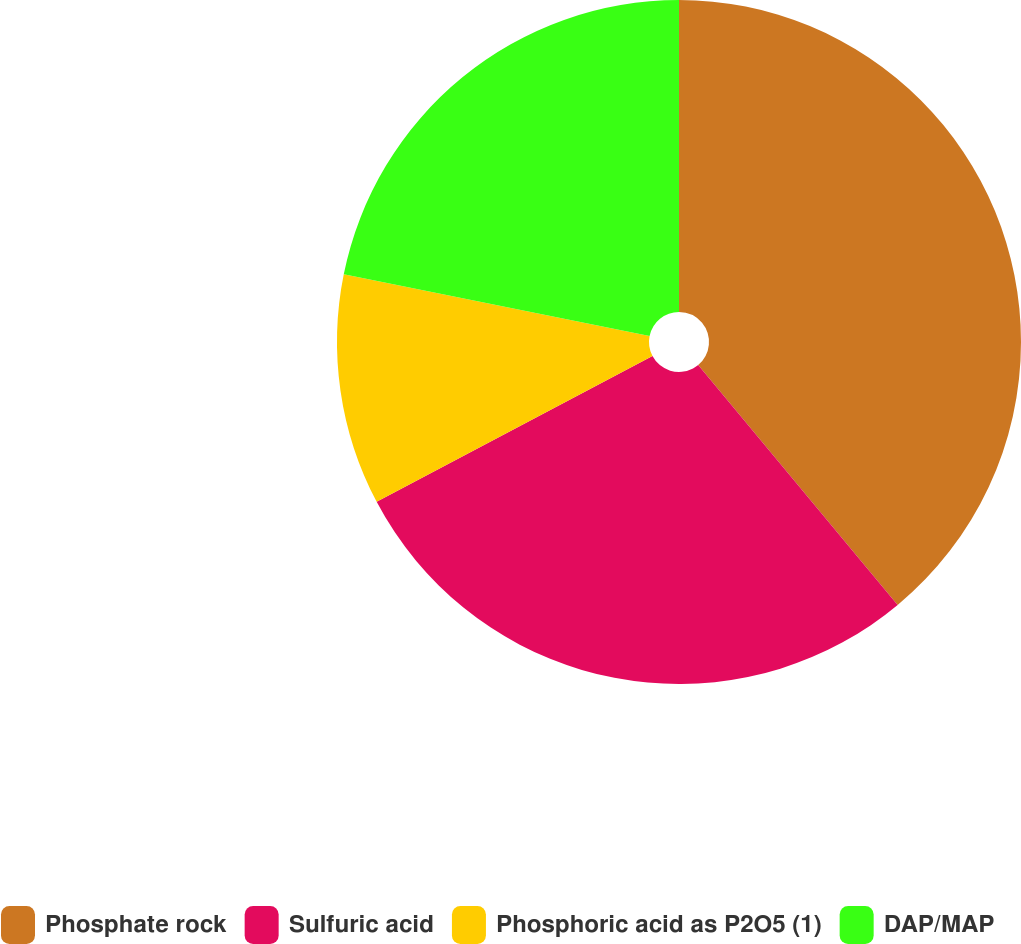<chart> <loc_0><loc_0><loc_500><loc_500><pie_chart><fcel>Phosphate rock<fcel>Sulfuric acid<fcel>Phosphoric acid as P2O5 (1)<fcel>DAP/MAP<nl><fcel>38.96%<fcel>28.3%<fcel>10.91%<fcel>21.83%<nl></chart> 